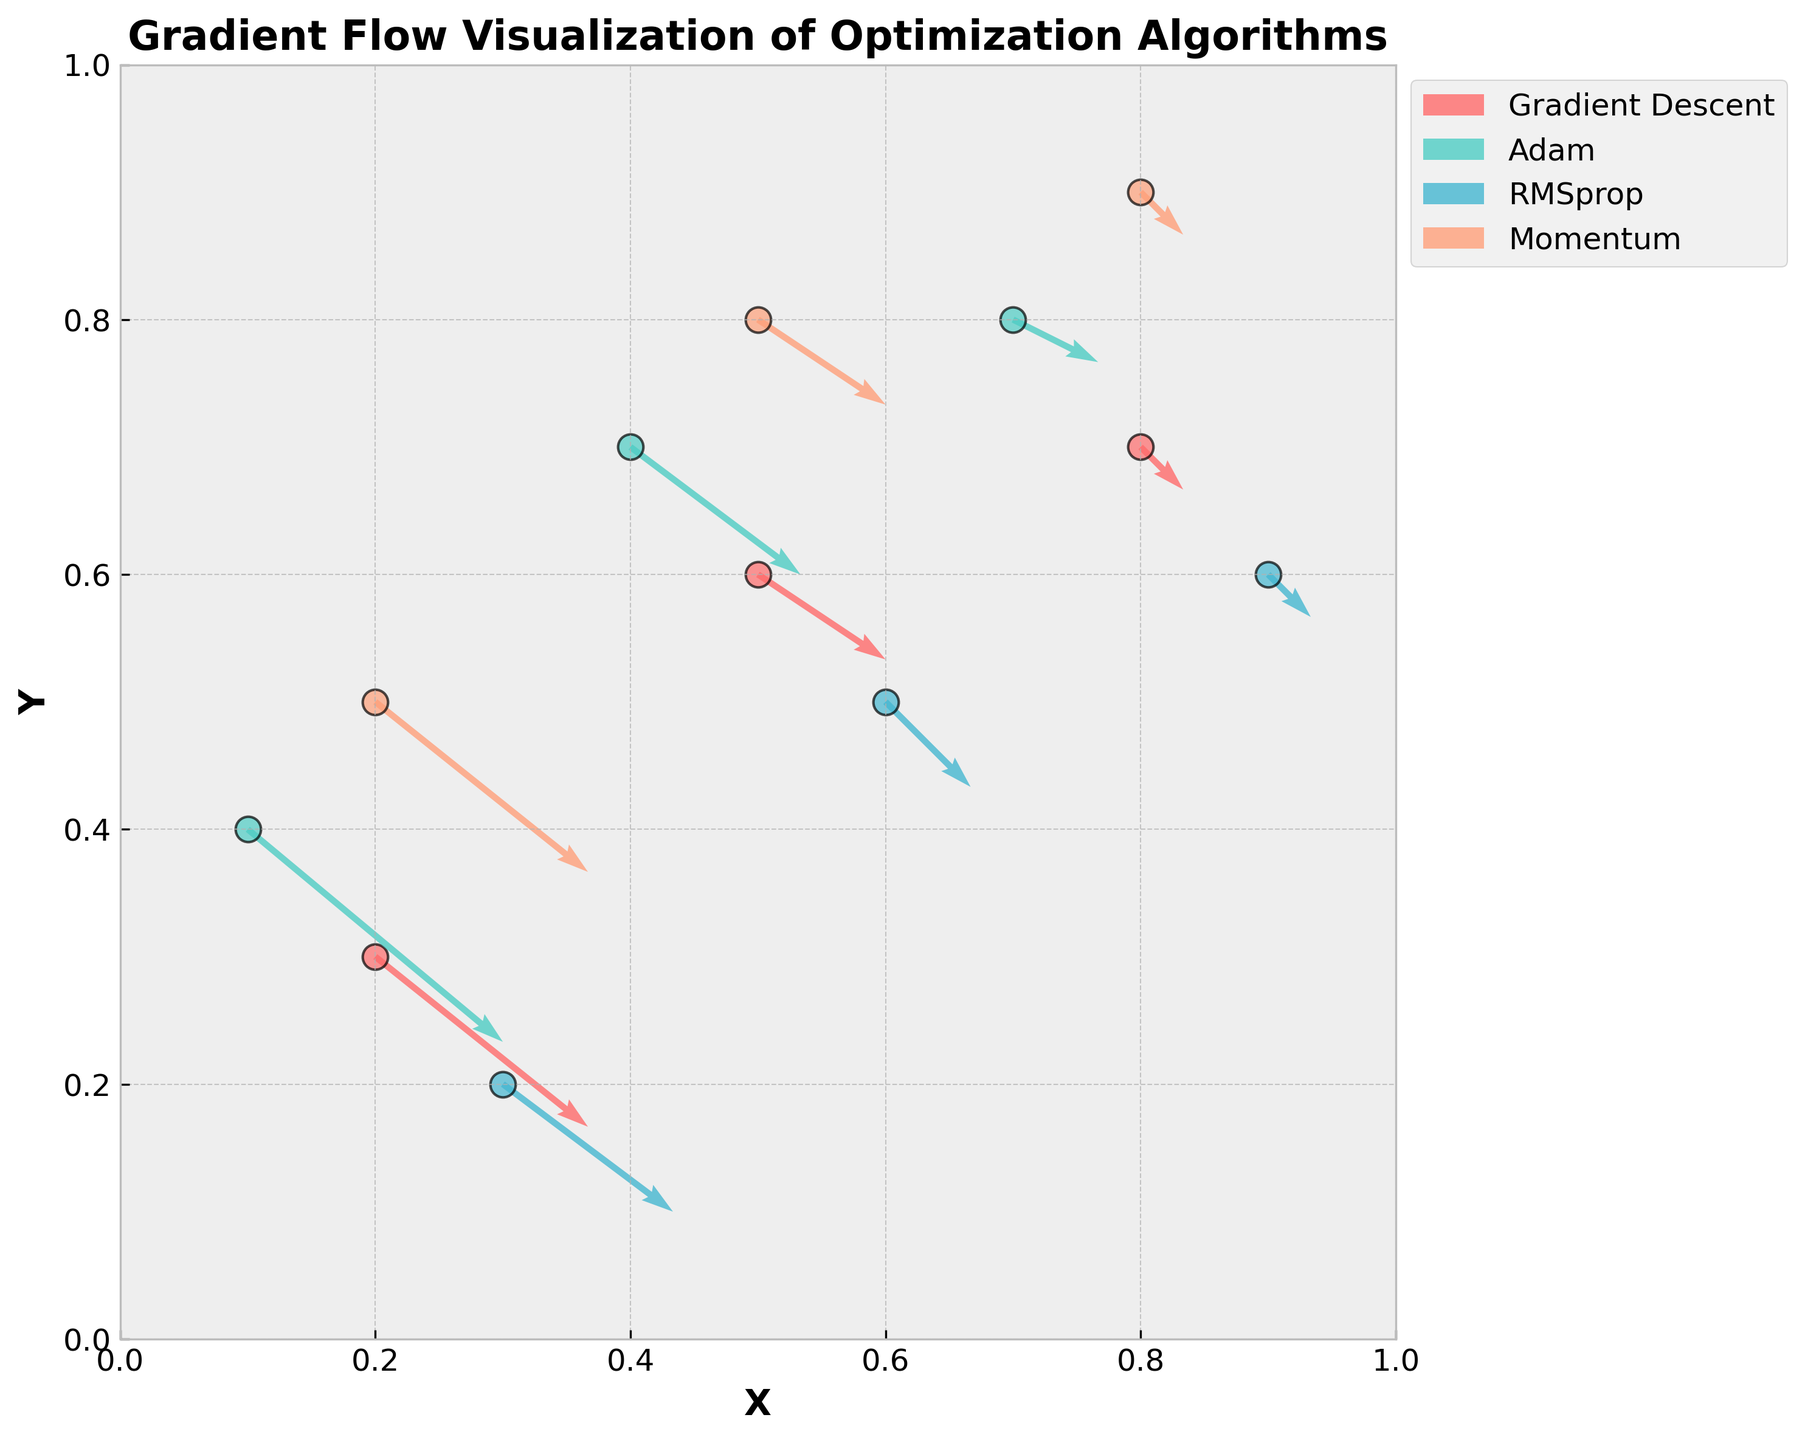How many optimization algorithms are displayed in the figure? The figure shows four different colors, each representing a distinct optimization algorithm.
Answer: 4 What are the axes labeled in the figure? The x-axis is labeled ‘X’ and the y-axis is labeled ‘Y’.
Answer: X and Y Which algorithm shows the longest arrow in the x-direction? For the longest arrow in the x-direction, we check the values of 'dx'. The Adam algorithm has a dx value of 0.6, which is the highest.
Answer: Adam What is the scale used in the quiver plot? The explanation mentions a scale of 3 is used in the quiver plot.
Answer: 3 Which algorithm has the point at the highest y-coordinate? By looking at the data points for each algorithm, the Momentum algorithm has a point at y = 0.9, which is the highest.
Answer: Momentum How many arrows are there for the RMSprop algorithm? We count the number of data points (or arrows) associated with RMSprop, which are 3.
Answer: 3 Compare the general direction of gradients for Gradient Descent and Adam algorithms. Which one shows steeper downward trends? By examining the dy values, Gradient Descent consistently has larger negative dy values compared to Adam, indicating steeper downward trends.
Answer: Gradient Descent What color is used to represent the Momentum algorithm in the plot? According to the code, fourth color in the list (last color) is used for Momentum, which appears to be light coral or orange.
Answer: Light Coral/Orange How does the overall length of vectors for RMSprop compare to Gradient Descent? By comparing the dx and dy values for each algorithm, vectors in RMSprop generally have smaller magnitudes compared to Gradient Descent.
Answer: RMSprop has smaller magnitudes Does any algorithm show a purely vertical (up or down) direction of gradient flow? To check for purely vertical vectors, dy should be non-zero while dx should be 0. None of the algorithms have such parameters.
Answer: No 